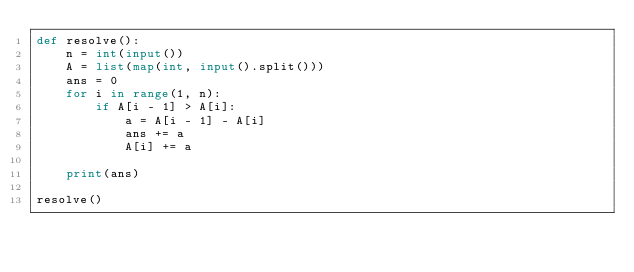Convert code to text. <code><loc_0><loc_0><loc_500><loc_500><_Python_>def resolve():
    n = int(input())
    A = list(map(int, input().split()))
    ans = 0
    for i in range(1, n):
        if A[i - 1] > A[i]:
            a = A[i - 1] - A[i]
            ans += a
            A[i] += a

    print(ans)

resolve()</code> 